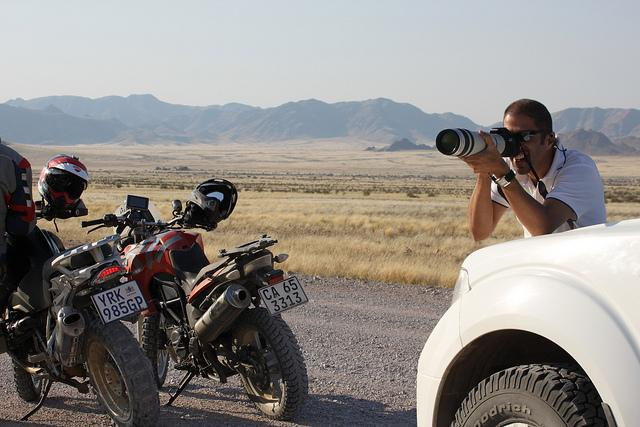How far away is the item being photographed? very far 